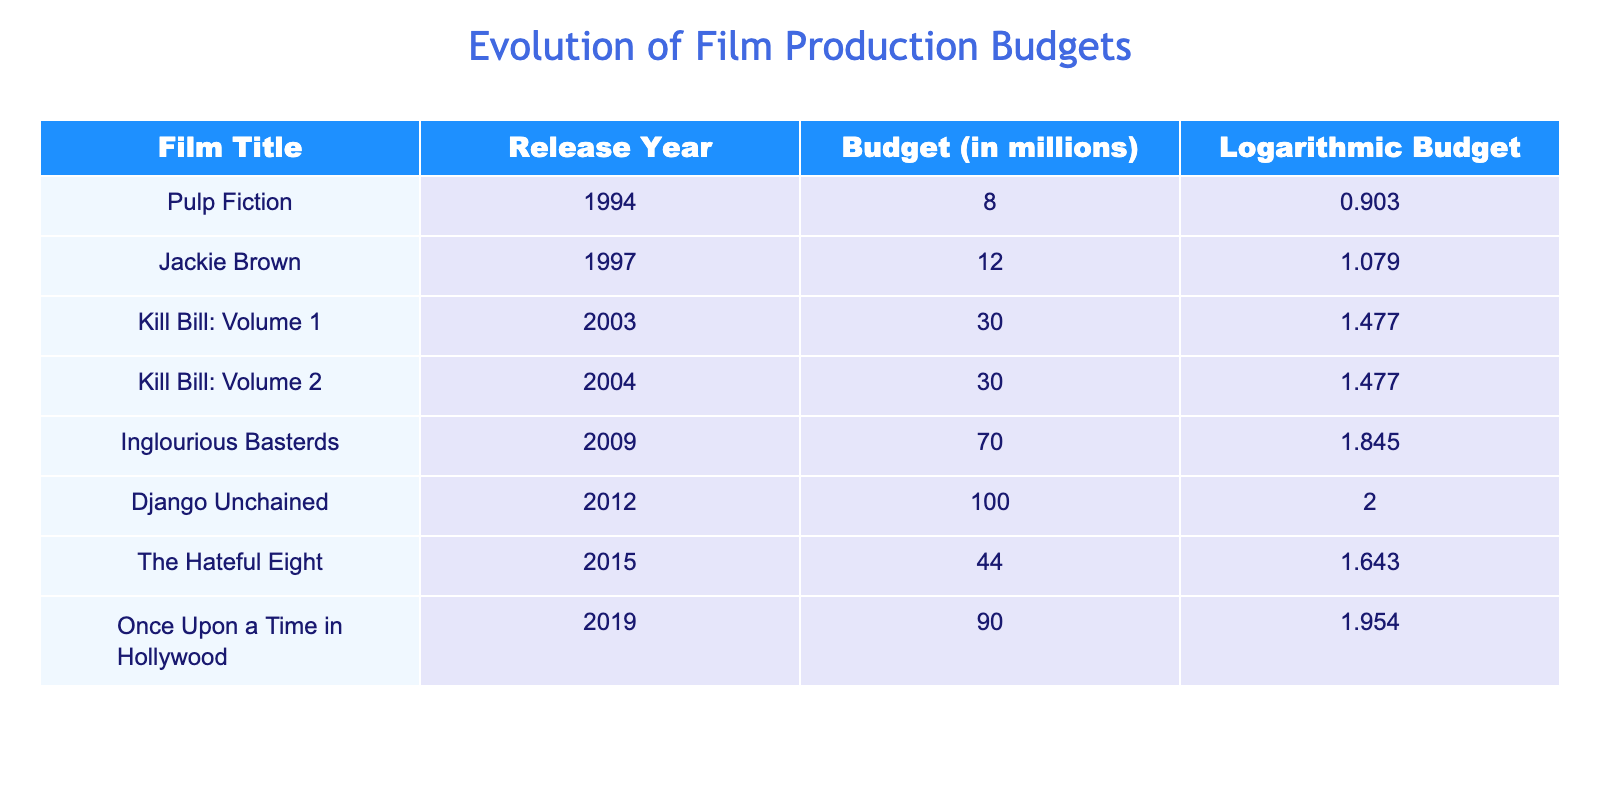What is the budget of 'Inglourious Basterds'? The budget for 'Inglourious Basterds' is explicitly listed in the table under the Budget column, which shows a value of 70.0 million.
Answer: 70.0 million Which film has the highest production budget? The table indicates that 'Django Unchained' has the highest budget at 100.0 million, as seen in the Budget column comparing all listed films.
Answer: 100.0 million What is the average budget of the films released between 2000 and 2010? The films released between 2000 and 2010 are 'Kill Bill: Volume 1,' 'Kill Bill: Volume 2,' 'Inglourious Basterds,' and 'Django Unchained.' Their budgets are 30.0, 30.0, 70.0, and 100.0 million respectively, totaling 230.0 million. This sum divided by 4 gives an average of 57.5 million.
Answer: 57.5 million Did 'Jackie Brown' have a lower budget than 'Pulp Fiction'? By comparing the budgets listed in the Budget column, 'Jackie Brown' costs 12.0 million and 'Pulp Fiction' costs 8.0 million. Since 12.0 million is greater than 8.0 million, the statement is false.
Answer: No Which films have a budget greater than the logarithmic budget value of 1.5? The films with logarithmic budget values exceeding 1.5 are 'Kill Bill: Volume 1,' 'Inglourious Basterds,' 'Django Unchained,' 'The Hateful Eight,' and 'Once Upon a Time in Hollywood.' Their corresponding budgets are 30.0, 70.0, 100.0, 44.0, and 90.0 million.
Answer: Kill Bill: Volume 1; Inglourious Basterds; Django Unchained; The Hateful Eight; Once Upon a Time in Hollywood What is the difference in budget between 'Once Upon a Time in Hollywood' and 'The Hateful Eight'? The budget of 'Once Upon a Time in Hollywood' is 90.0 million and for 'The Hateful Eight' it is 44.0 million. Subtracting these values gives 90.0 - 44.0 = 46.0 million.
Answer: 46.0 million 